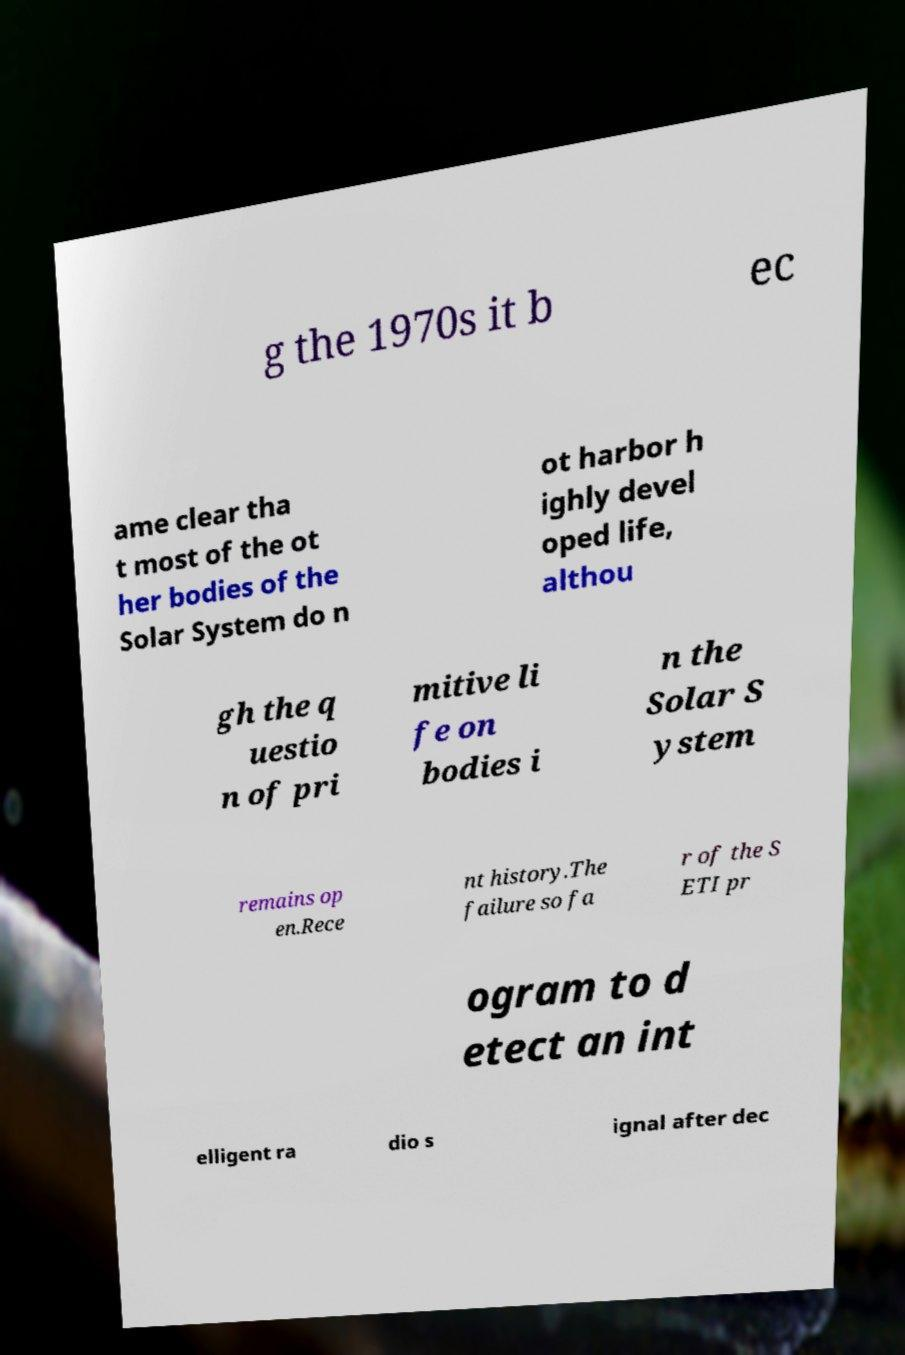Please read and relay the text visible in this image. What does it say? g the 1970s it b ec ame clear tha t most of the ot her bodies of the Solar System do n ot harbor h ighly devel oped life, althou gh the q uestio n of pri mitive li fe on bodies i n the Solar S ystem remains op en.Rece nt history.The failure so fa r of the S ETI pr ogram to d etect an int elligent ra dio s ignal after dec 